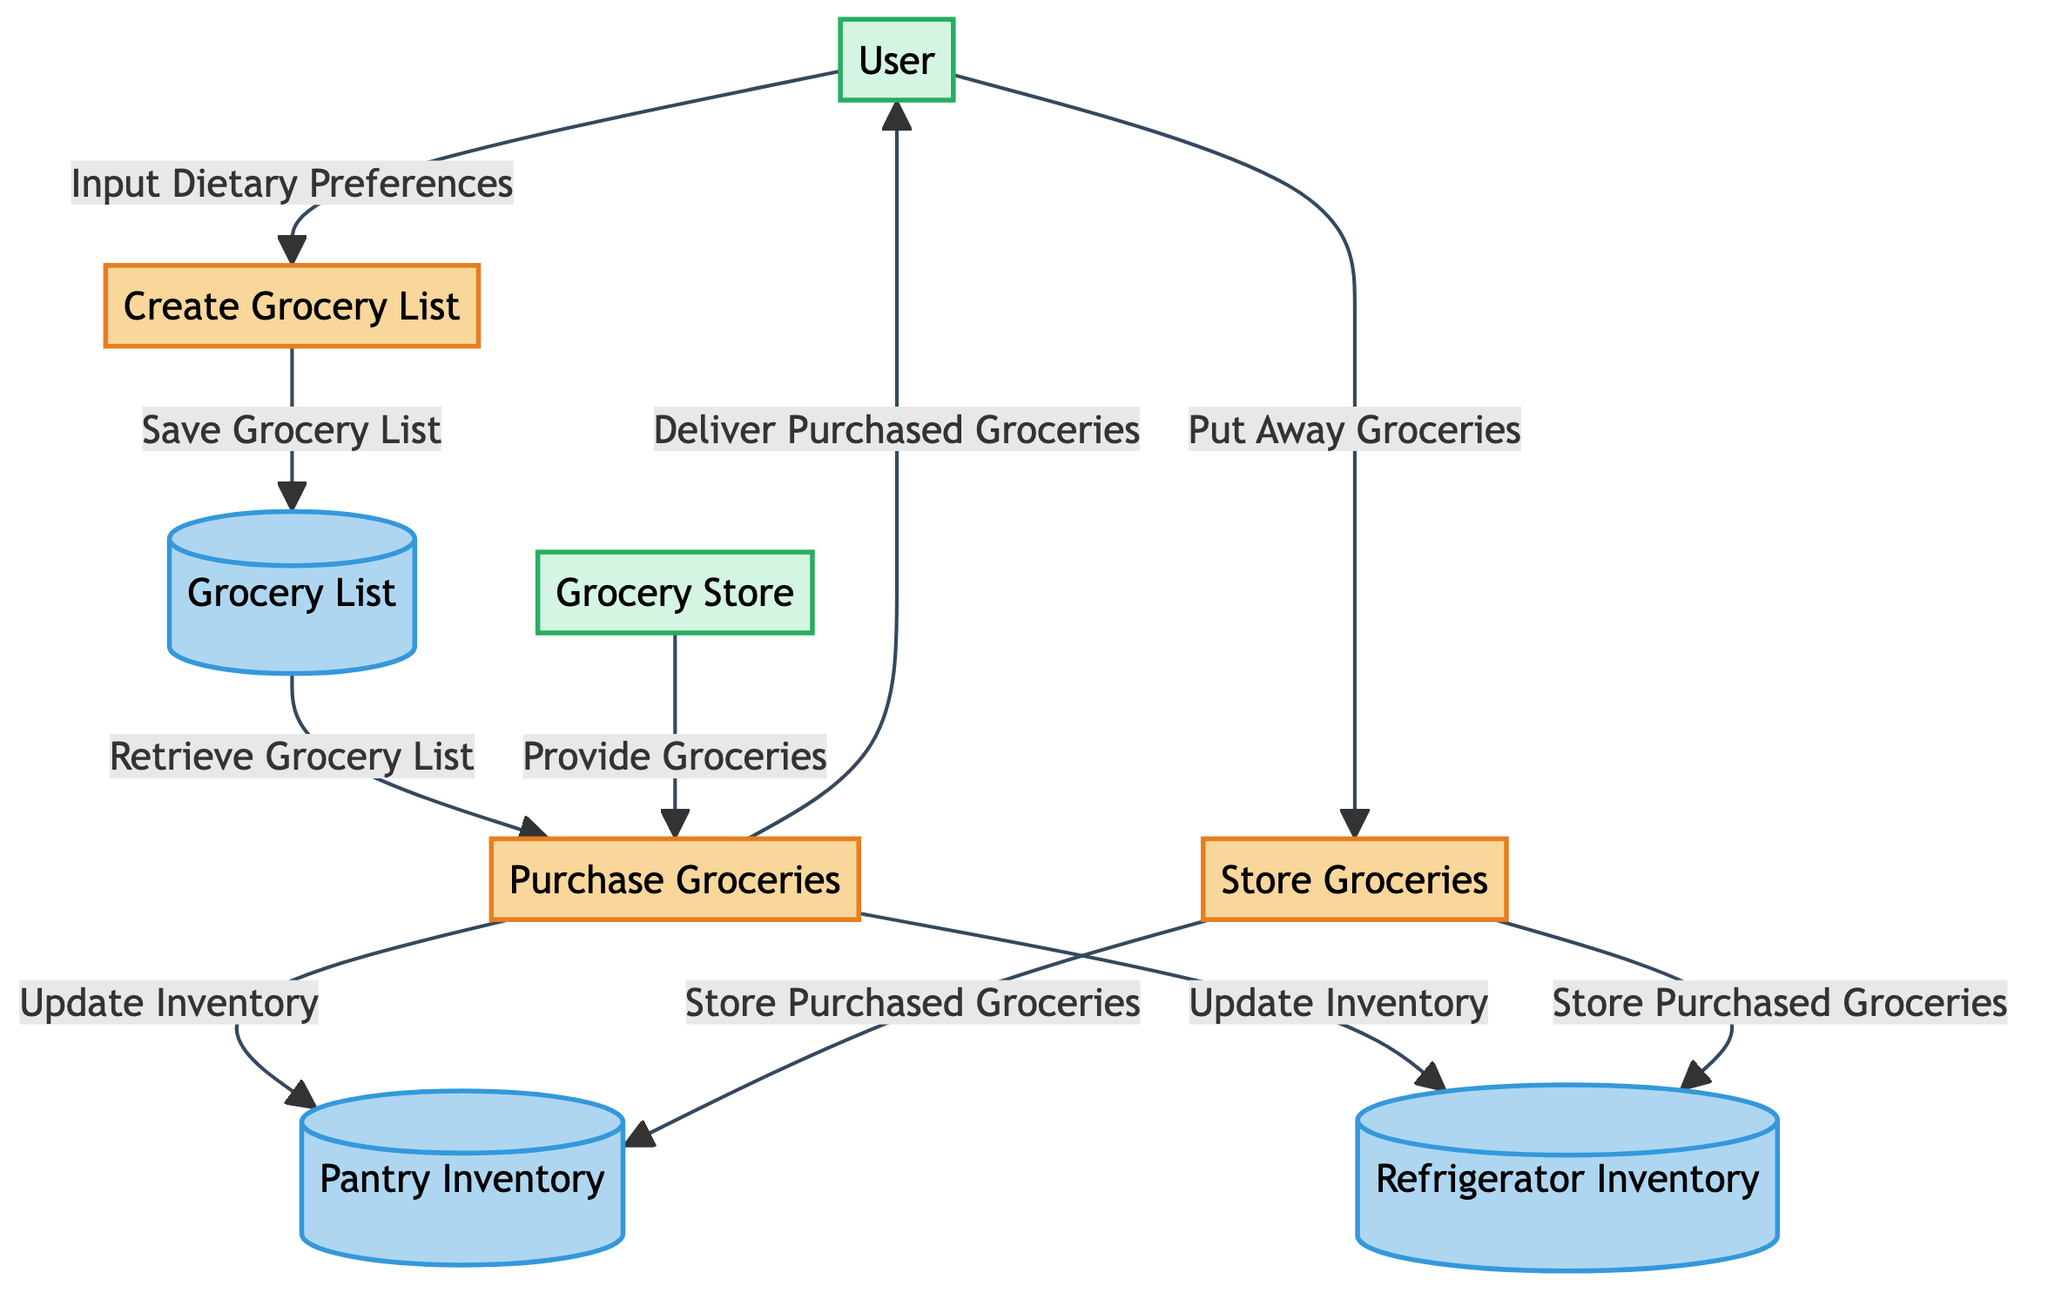What are the processes involved in the grocery shopping process? The diagram lists three processes: Create Grocery List, Purchase Groceries, and Store Groceries. These are visualized as nodes in the diagram.
Answer: Create Grocery List, Purchase Groceries, Store Groceries How many data stores are present in the diagram? The diagram contains three data stores: Pantry Inventory, Refrigerator Inventory, and Grocery List, which can be counted from the nodes labeled as data stores.
Answer: 3 Who provides the groceries in this process? The Grocery Store is identified as the external entity that provides groceries during the Purchase Groceries process, as shown by the directed flow from E2 to P2 labeled "Provide Groceries."
Answer: Grocery Store What does the User input into the Create Grocery List process? The User inputs their dietary preferences into the process of creating the grocery list, as indicated by the directed flow labeled "Input Dietary Preferences" from E1 to P1.
Answer: Dietary Preferences How are the inventories updated after purchasing groceries? After the Purchase Groceries process, the inventory for both the Pantry and Refrigerator is updated, as indicated by the directed flows labeled "Update Inventory" from P2 to D1 and D2.
Answer: Update Inventory Which process follows after the groceries are delivered? After the groceries are delivered to the User, the next process in the flow is "Put Away Groceries," as shown by the directed flow from P2 to P3.
Answer: Put Away Groceries What are the data flows coming out of the Purchase Groceries process? The Purchase Groceries process has multiple outgoing data flows: "Deliver Purchased Groceries" to the User (E1) and "Update Inventory" to both Pantry Inventory (D1) and Refrigerator Inventory (D2). This is identified by examining the connections from P2.
Answer: Deliver Purchased Groceries, Update Inventory Which entities are part of the grocery shopping process depicted here? The external entities in this diagram are the User and the Grocery Store, which are represented as nodes with labels for each entity.
Answer: User, Grocery Store What is the purpose of the Grocery List data store? The Grocery List serves to store the saved list of groceries created by the User, as indicated by the directed flow labeled "Save Grocery List" from P1 to D3.
Answer: Save Grocery List 